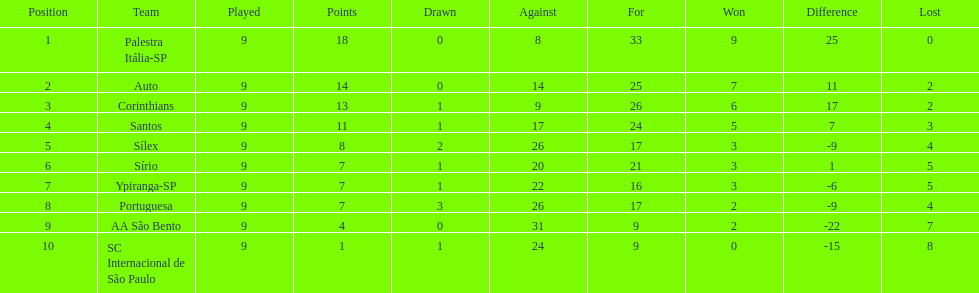Which team was the top scoring team? Palestra Itália-SP. 